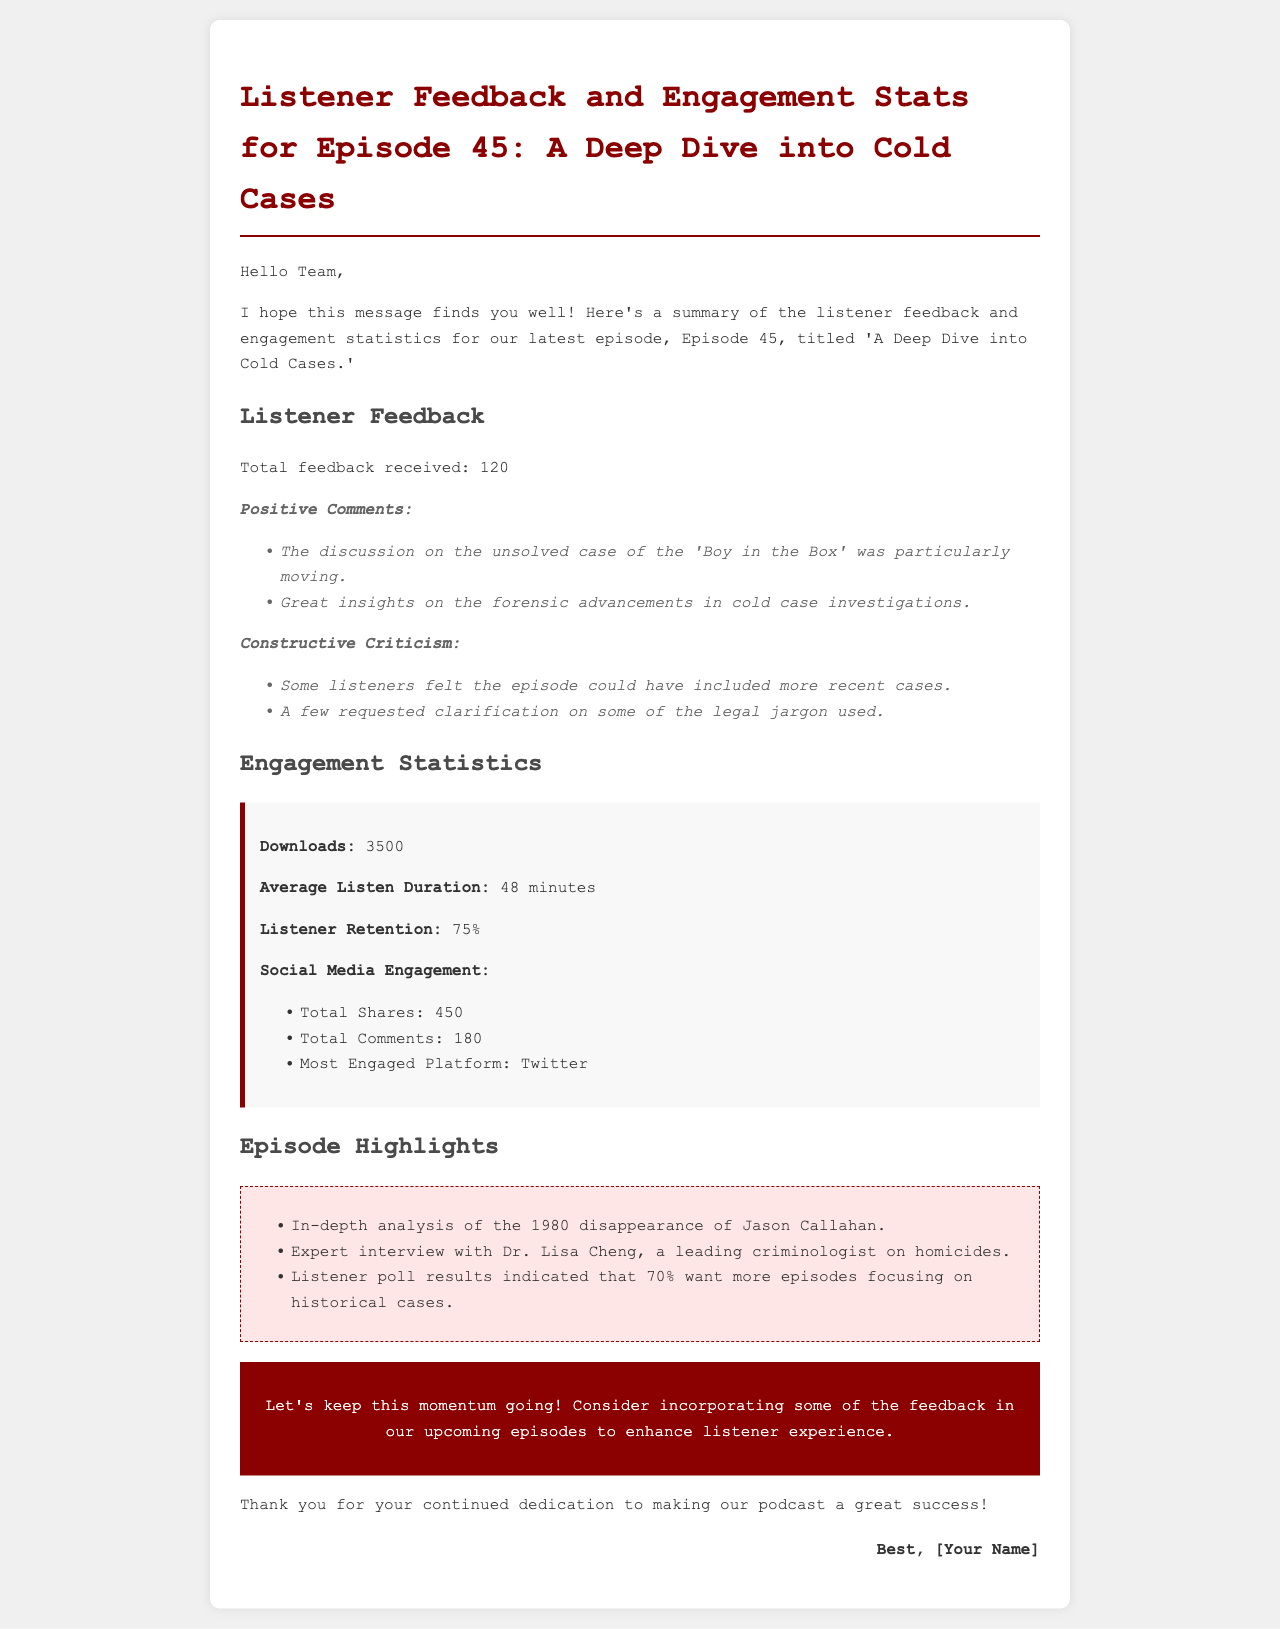What is the title of Episode 45? The title is specified in the document as 'A Deep Dive into Cold Cases.'
Answer: A Deep Dive into Cold Cases How many total feedbacks were received? The document states that a total of 120 feedbacks were received for the episode.
Answer: 120 What is the average listen duration for this episode? The average listen duration mentioned in the document is 48 minutes.
Answer: 48 minutes What was the most engaged platform on social media? The document indicates that Twitter was the most engaged platform for social media interactions.
Answer: Twitter What percentage of listeners want more episodes focusing on historical cases? The document reveals that 70% of listeners indicated this preference in the listener poll results.
Answer: 70% Which case did the in-depth analysis focus on? The document states that the analysis focused on the 1980 disappearance of Jason Callahan.
Answer: 1980 disappearance of Jason Callahan What was one piece of constructive criticism mentioned by listeners? The document mentions that some listeners felt the episode could have included more recent cases.
Answer: More recent cases How many total shares were noted in the social media engagement statistics? The document states that there were 450 total shares.
Answer: 450 What does the call-to-action encourage? The call-to-action urges the team to incorporate feedback in upcoming episodes to enhance listener experience.
Answer: Incorporating feedback in upcoming episodes 